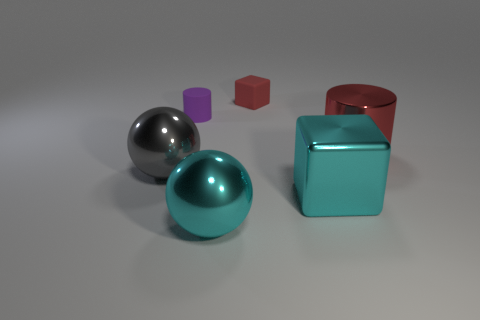What color is the tiny rubber cylinder?
Your answer should be compact. Purple. What shape is the big shiny object that is the same color as the tiny cube?
Give a very brief answer. Cylinder. Are any tiny green balls visible?
Your answer should be compact. No. What size is the gray thing that is the same material as the large cyan ball?
Your answer should be compact. Large. There is a tiny rubber object right of the tiny object left of the block that is behind the large metallic block; what shape is it?
Provide a short and direct response. Cube. Are there an equal number of red rubber things in front of the large gray metal ball and small cubes?
Give a very brief answer. No. What is the size of the cylinder that is the same color as the small rubber block?
Offer a very short reply. Large. Is the red metal thing the same shape as the small red object?
Provide a succinct answer. No. What number of objects are either cylinders in front of the rubber block or cyan metal blocks?
Provide a succinct answer. 3. Is the number of small purple cylinders in front of the tiny cylinder the same as the number of metal things behind the cyan sphere?
Offer a very short reply. No. 